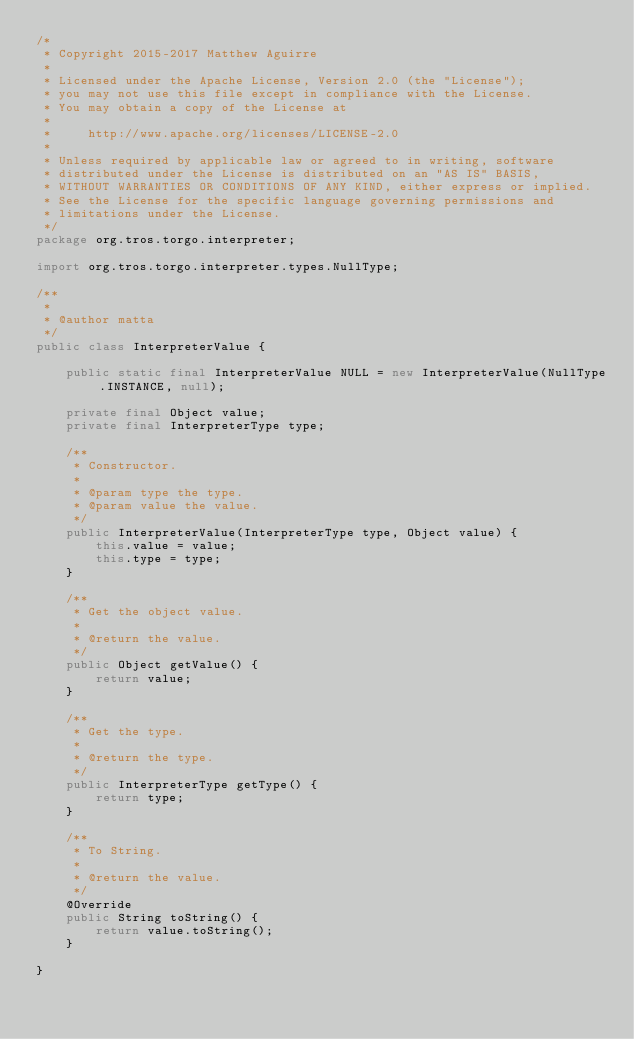Convert code to text. <code><loc_0><loc_0><loc_500><loc_500><_Java_>/*
 * Copyright 2015-2017 Matthew Aguirre
 *
 * Licensed under the Apache License, Version 2.0 (the "License");
 * you may not use this file except in compliance with the License.
 * You may obtain a copy of the License at
 *
 *     http://www.apache.org/licenses/LICENSE-2.0
 *
 * Unless required by applicable law or agreed to in writing, software
 * distributed under the License is distributed on an "AS IS" BASIS,
 * WITHOUT WARRANTIES OR CONDITIONS OF ANY KIND, either express or implied.
 * See the License for the specific language governing permissions and
 * limitations under the License.
 */
package org.tros.torgo.interpreter;

import org.tros.torgo.interpreter.types.NullType;

/**
 *
 * @author matta
 */
public class InterpreterValue {

    public static final InterpreterValue NULL = new InterpreterValue(NullType.INSTANCE, null);

    private final Object value;
    private final InterpreterType type;

    /**
     * Constructor.
     *
     * @param type the type.
     * @param value the value.
     */
    public InterpreterValue(InterpreterType type, Object value) {
        this.value = value;
        this.type = type;
    }

    /**
     * Get the object value.
     *
     * @return the value.
     */
    public Object getValue() {
        return value;
    }

    /**
     * Get the type.
     *
     * @return the type.
     */
    public InterpreterType getType() {
        return type;
    }

    /**
     * To String.
     *
     * @return the value.
     */
    @Override
    public String toString() {
        return value.toString();
    }

}
</code> 